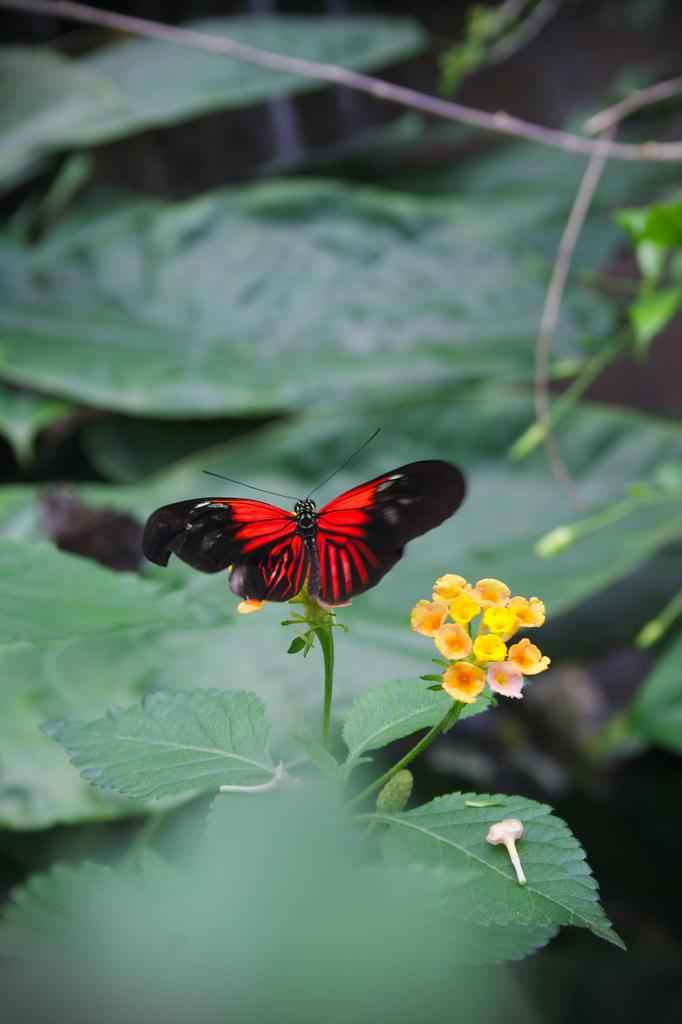What type of insect is in the image? There is a butterfly in the image. What colors can be seen on the butterfly? The butterfly has red and black colors. What other living organisms are present in the image? There are flowers in the image. What colors can be seen on the flowers? The flowers have yellow, orange, and pink colors. What can be seen in the background of the image? The background of the image includes leaves. What color are the leaves? The leaves have a green color. What type of badge is hanging on the frame in the image? There is no badge or frame present in the image; it features a butterfly, flowers, and leaves. 